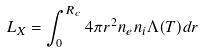Convert formula to latex. <formula><loc_0><loc_0><loc_500><loc_500>L _ { X } = \int _ { 0 } ^ { R _ { c } } 4 \pi r ^ { 2 } n _ { e } n _ { i } \Lambda ( T ) d r</formula> 